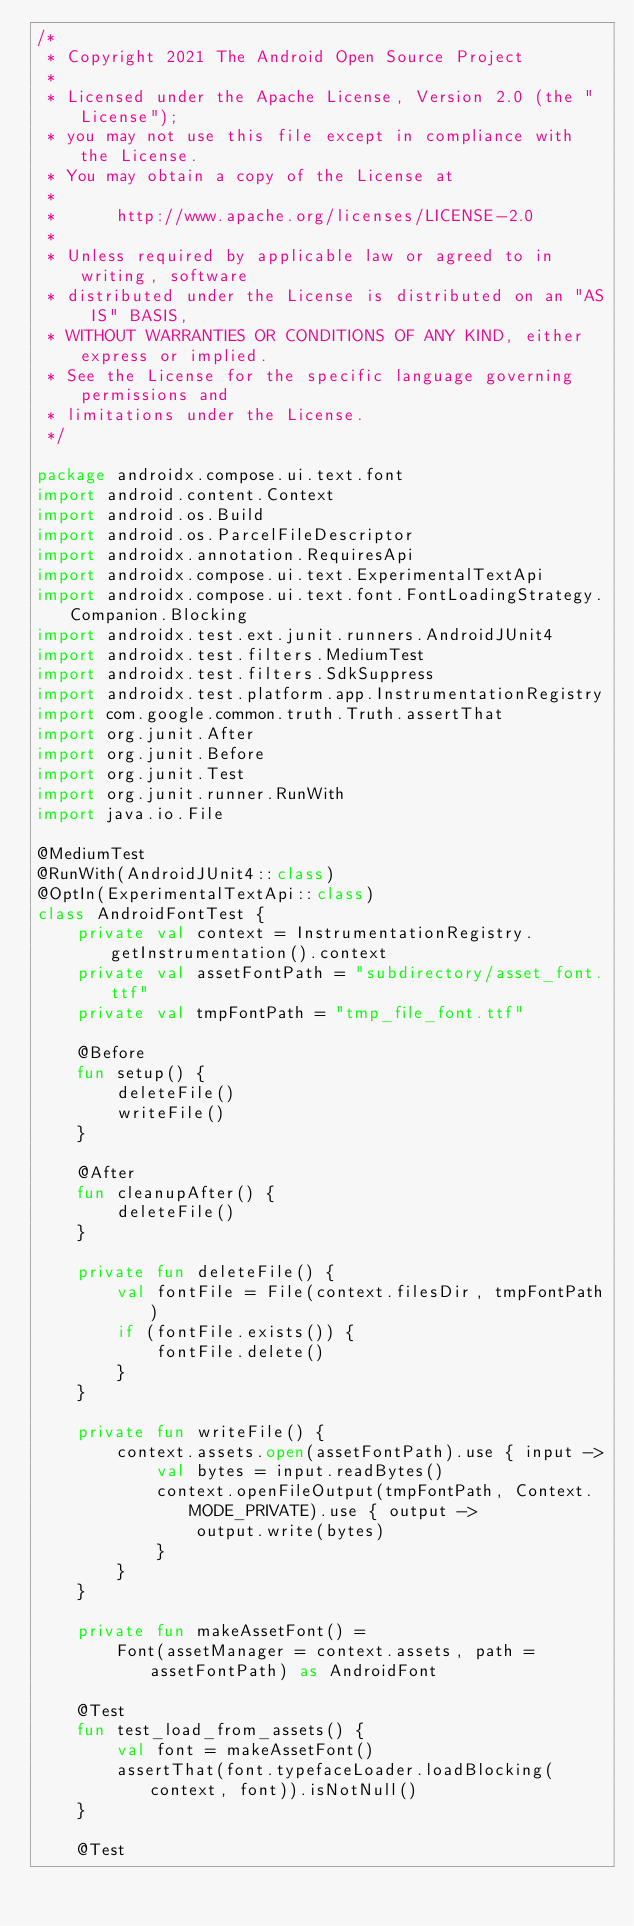<code> <loc_0><loc_0><loc_500><loc_500><_Kotlin_>/*
 * Copyright 2021 The Android Open Source Project
 *
 * Licensed under the Apache License, Version 2.0 (the "License");
 * you may not use this file except in compliance with the License.
 * You may obtain a copy of the License at
 *
 *      http://www.apache.org/licenses/LICENSE-2.0
 *
 * Unless required by applicable law or agreed to in writing, software
 * distributed under the License is distributed on an "AS IS" BASIS,
 * WITHOUT WARRANTIES OR CONDITIONS OF ANY KIND, either express or implied.
 * See the License for the specific language governing permissions and
 * limitations under the License.
 */

package androidx.compose.ui.text.font
import android.content.Context
import android.os.Build
import android.os.ParcelFileDescriptor
import androidx.annotation.RequiresApi
import androidx.compose.ui.text.ExperimentalTextApi
import androidx.compose.ui.text.font.FontLoadingStrategy.Companion.Blocking
import androidx.test.ext.junit.runners.AndroidJUnit4
import androidx.test.filters.MediumTest
import androidx.test.filters.SdkSuppress
import androidx.test.platform.app.InstrumentationRegistry
import com.google.common.truth.Truth.assertThat
import org.junit.After
import org.junit.Before
import org.junit.Test
import org.junit.runner.RunWith
import java.io.File

@MediumTest
@RunWith(AndroidJUnit4::class)
@OptIn(ExperimentalTextApi::class)
class AndroidFontTest {
    private val context = InstrumentationRegistry.getInstrumentation().context
    private val assetFontPath = "subdirectory/asset_font.ttf"
    private val tmpFontPath = "tmp_file_font.ttf"

    @Before
    fun setup() {
        deleteFile()
        writeFile()
    }

    @After
    fun cleanupAfter() {
        deleteFile()
    }

    private fun deleteFile() {
        val fontFile = File(context.filesDir, tmpFontPath)
        if (fontFile.exists()) {
            fontFile.delete()
        }
    }

    private fun writeFile() {
        context.assets.open(assetFontPath).use { input ->
            val bytes = input.readBytes()
            context.openFileOutput(tmpFontPath, Context.MODE_PRIVATE).use { output ->
                output.write(bytes)
            }
        }
    }

    private fun makeAssetFont() =
        Font(assetManager = context.assets, path = assetFontPath) as AndroidFont

    @Test
    fun test_load_from_assets() {
        val font = makeAssetFont()
        assertThat(font.typefaceLoader.loadBlocking(context, font)).isNotNull()
    }

    @Test</code> 